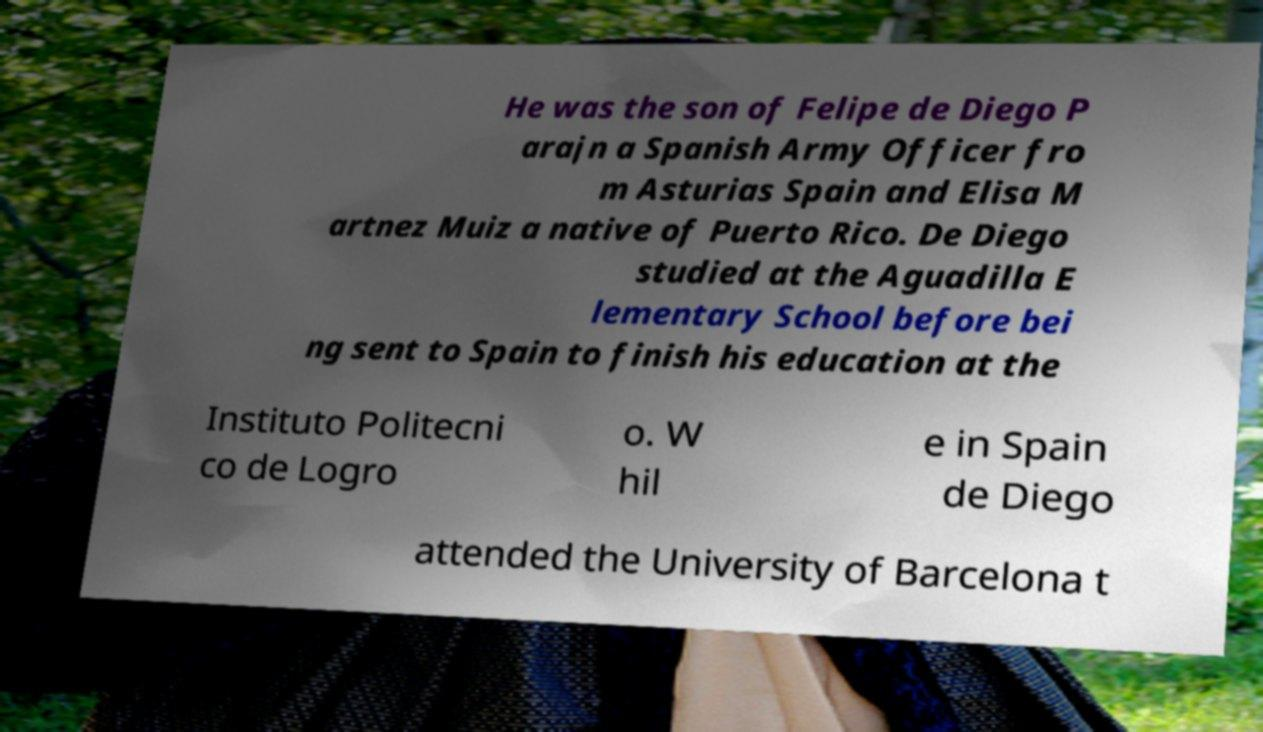Please read and relay the text visible in this image. What does it say? He was the son of Felipe de Diego P arajn a Spanish Army Officer fro m Asturias Spain and Elisa M artnez Muiz a native of Puerto Rico. De Diego studied at the Aguadilla E lementary School before bei ng sent to Spain to finish his education at the Instituto Politecni co de Logro o. W hil e in Spain de Diego attended the University of Barcelona t 